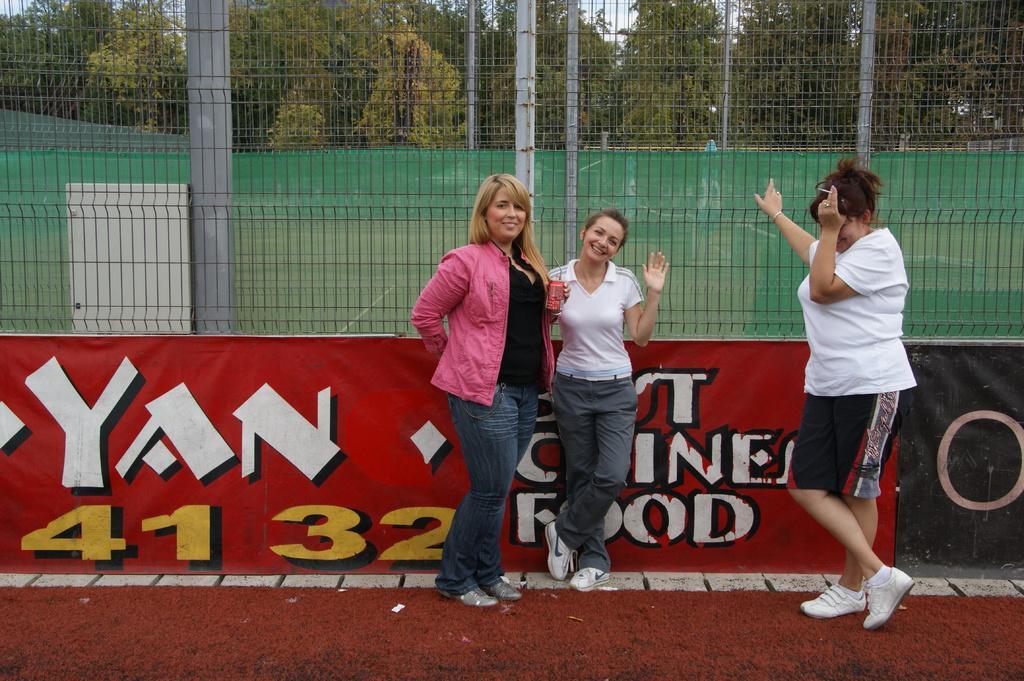Please provide a concise description of this image. There are three ladies standing. One lady is wearing a jacket and holding something in the hand. In the back there is a banner. Also there is a mesh fencing. In the background there are poles and trees. 